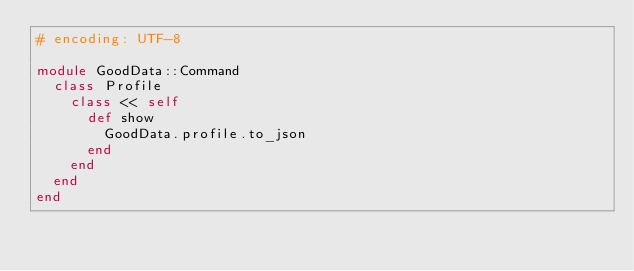Convert code to text. <code><loc_0><loc_0><loc_500><loc_500><_Ruby_># encoding: UTF-8

module GoodData::Command
  class Profile
    class << self
      def show
        GoodData.profile.to_json
      end
    end
  end
end</code> 